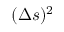Convert formula to latex. <formula><loc_0><loc_0><loc_500><loc_500>( \Delta { s } ) ^ { 2 }</formula> 